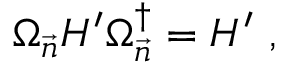Convert formula to latex. <formula><loc_0><loc_0><loc_500><loc_500>\Omega _ { \vec { n } } H ^ { \prime } \Omega _ { \vec { n } } ^ { \dagger } = H ^ { \prime } \ ,</formula> 